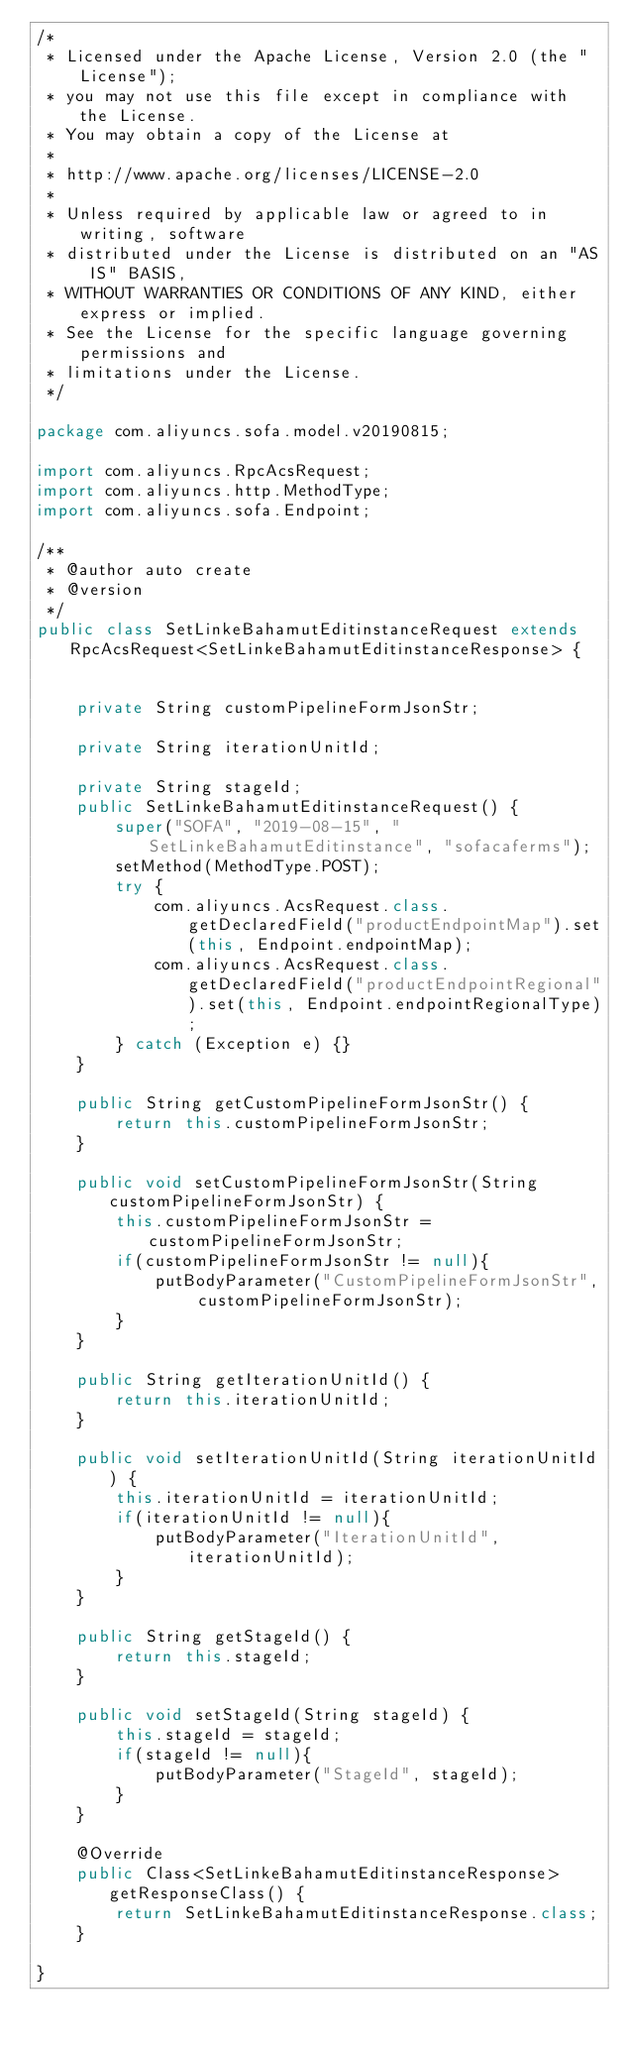<code> <loc_0><loc_0><loc_500><loc_500><_Java_>/*
 * Licensed under the Apache License, Version 2.0 (the "License");
 * you may not use this file except in compliance with the License.
 * You may obtain a copy of the License at
 *
 * http://www.apache.org/licenses/LICENSE-2.0
 *
 * Unless required by applicable law or agreed to in writing, software
 * distributed under the License is distributed on an "AS IS" BASIS,
 * WITHOUT WARRANTIES OR CONDITIONS OF ANY KIND, either express or implied.
 * See the License for the specific language governing permissions and
 * limitations under the License.
 */

package com.aliyuncs.sofa.model.v20190815;

import com.aliyuncs.RpcAcsRequest;
import com.aliyuncs.http.MethodType;
import com.aliyuncs.sofa.Endpoint;

/**
 * @author auto create
 * @version 
 */
public class SetLinkeBahamutEditinstanceRequest extends RpcAcsRequest<SetLinkeBahamutEditinstanceResponse> {
	   

	private String customPipelineFormJsonStr;

	private String iterationUnitId;

	private String stageId;
	public SetLinkeBahamutEditinstanceRequest() {
		super("SOFA", "2019-08-15", "SetLinkeBahamutEditinstance", "sofacaferms");
		setMethod(MethodType.POST);
		try {
			com.aliyuncs.AcsRequest.class.getDeclaredField("productEndpointMap").set(this, Endpoint.endpointMap);
			com.aliyuncs.AcsRequest.class.getDeclaredField("productEndpointRegional").set(this, Endpoint.endpointRegionalType);
		} catch (Exception e) {}
	}

	public String getCustomPipelineFormJsonStr() {
		return this.customPipelineFormJsonStr;
	}

	public void setCustomPipelineFormJsonStr(String customPipelineFormJsonStr) {
		this.customPipelineFormJsonStr = customPipelineFormJsonStr;
		if(customPipelineFormJsonStr != null){
			putBodyParameter("CustomPipelineFormJsonStr", customPipelineFormJsonStr);
		}
	}

	public String getIterationUnitId() {
		return this.iterationUnitId;
	}

	public void setIterationUnitId(String iterationUnitId) {
		this.iterationUnitId = iterationUnitId;
		if(iterationUnitId != null){
			putBodyParameter("IterationUnitId", iterationUnitId);
		}
	}

	public String getStageId() {
		return this.stageId;
	}

	public void setStageId(String stageId) {
		this.stageId = stageId;
		if(stageId != null){
			putBodyParameter("StageId", stageId);
		}
	}

	@Override
	public Class<SetLinkeBahamutEditinstanceResponse> getResponseClass() {
		return SetLinkeBahamutEditinstanceResponse.class;
	}

}
</code> 